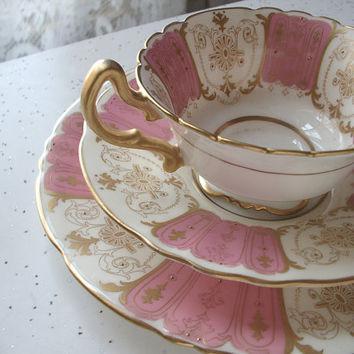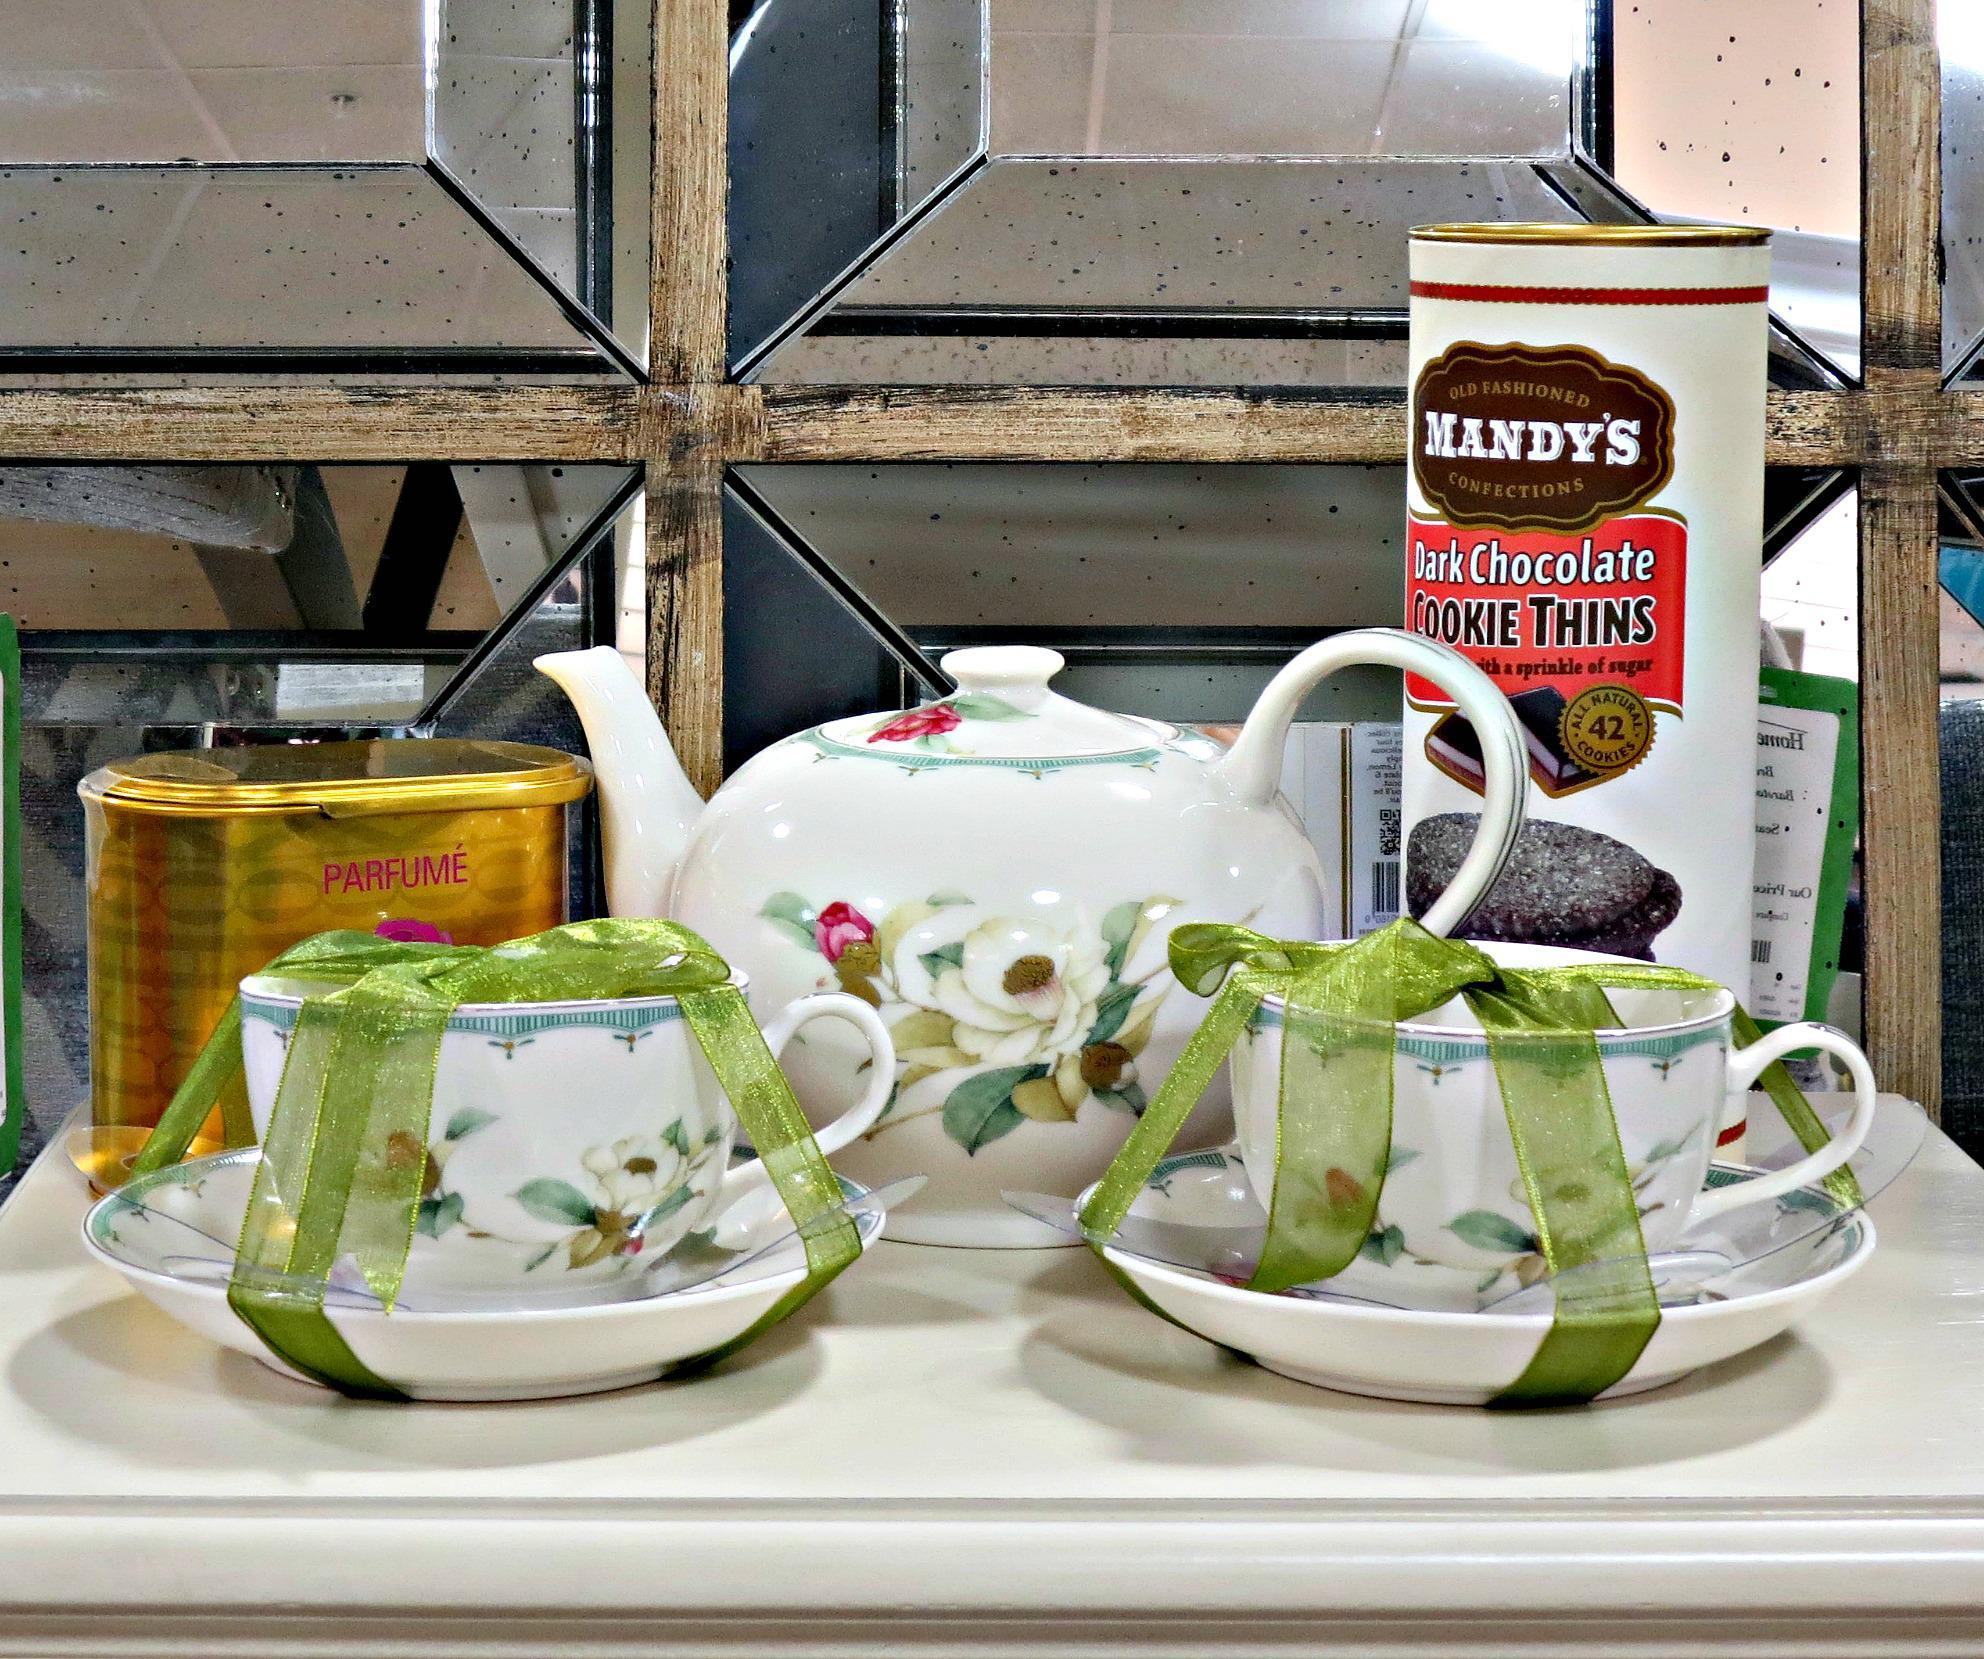The first image is the image on the left, the second image is the image on the right. Given the left and right images, does the statement "One of the teacups is blue with pink flowers on it." hold true? Answer yes or no. No. The first image is the image on the left, the second image is the image on the right. For the images shown, is this caption "No more than one tea pot is visible." true? Answer yes or no. Yes. 